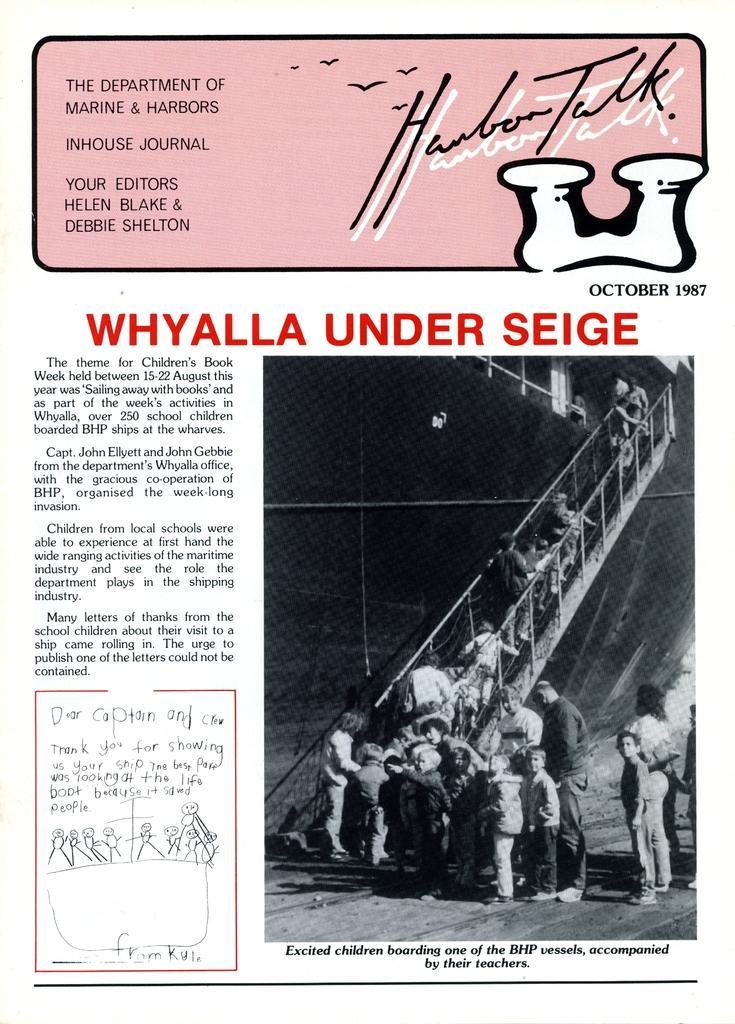Describe this image in one or two sentences. There is a poster. There is a black and white image at the right. People are standing on the stairs and other people are standing on the floor. 